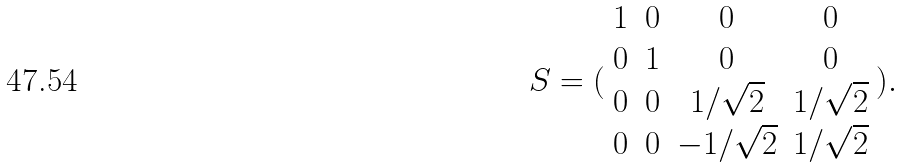Convert formula to latex. <formula><loc_0><loc_0><loc_500><loc_500>S = ( \begin{array} { c c c c } 1 & 0 & 0 & 0 \\ 0 & 1 & 0 & 0 \\ 0 & 0 & 1 / \sqrt { 2 } & 1 / \sqrt { 2 } \\ 0 & 0 & - 1 / \sqrt { 2 } & 1 / \sqrt { 2 } \end{array} ) .</formula> 